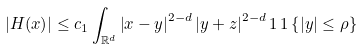<formula> <loc_0><loc_0><loc_500><loc_500>| H ( x ) | \leq c _ { 1 } \int _ { \mathbb { R } ^ { d } } { \left | x - y \right | ^ { 2 - d } \left | y + z \right | ^ { 2 - d } 1 \, 1 \left \{ | y | \leq \rho \right \} }</formula> 